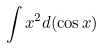Convert formula to latex. <formula><loc_0><loc_0><loc_500><loc_500>\int x ^ { 2 } d ( \cos x )</formula> 